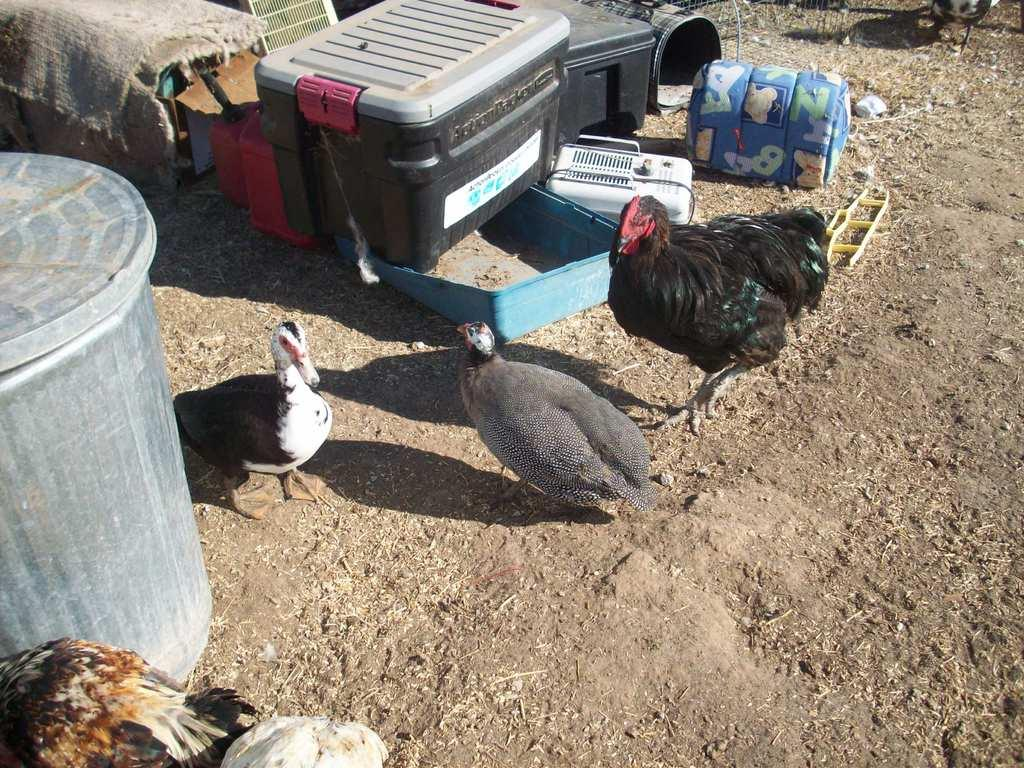What type of animals can be seen in the image? There are birds in the image. What type of container is visible in the image? There is a bag in the image. What type of storage containers are present in the image? There are boxes in the image. What type of large cylindrical container is in the image? There is a barrel in the image. What type of material is present in the image that allows for airflow? There is mesh in the image. What type of objects can be seen on the surface in the image? There are objects on the surface in the image. What type of trail can be seen in the image? There is no trail present in the image. 